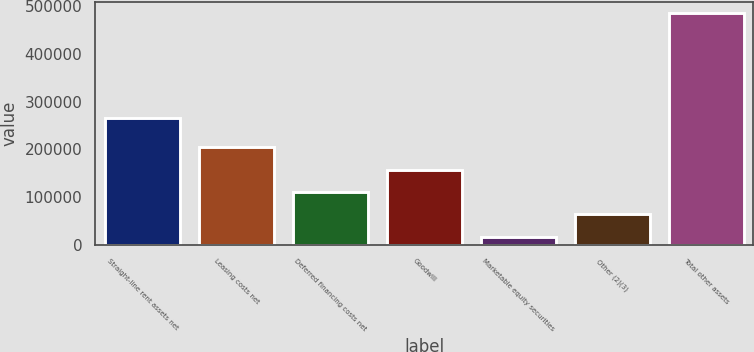Convert chart. <chart><loc_0><loc_0><loc_500><loc_500><bar_chart><fcel>Straight-line rent assets net<fcel>Leasing costs net<fcel>Deferred financing costs net<fcel>Goodwill<fcel>Marketable equity securities<fcel>Other (2)(3)<fcel>Total other assets<nl><fcel>266620<fcel>204415<fcel>110734<fcel>157574<fcel>17053<fcel>63893.5<fcel>485458<nl></chart> 